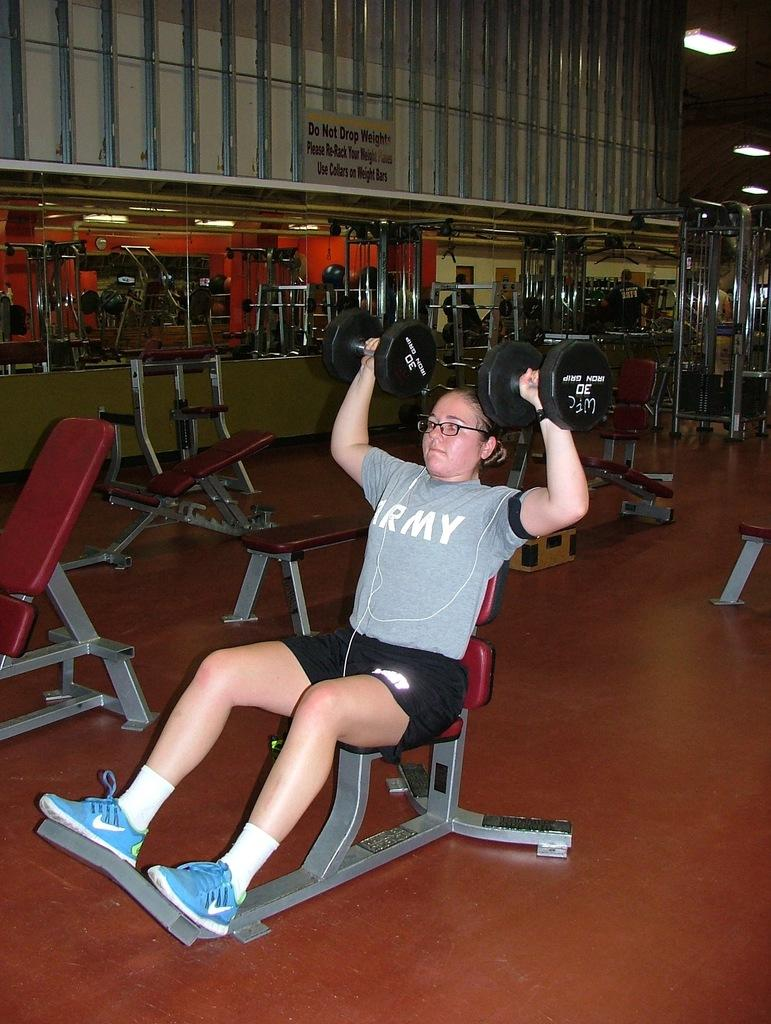Who is the main subject in the image? There is a woman in the image. What is the woman doing in the image? The woman is sitting on a chair and lifting weights. Can you describe the setting of the image? The image is a reflection in a mirror. What type of street can be seen in the image? There is no street visible in the image, as it is a reflection in a mirror. How does the woman expand her muscles while lifting weights in the image? The image does not show the woman expanding her muscles; it only shows her lifting weights. 